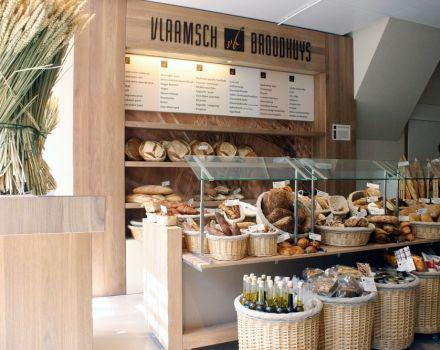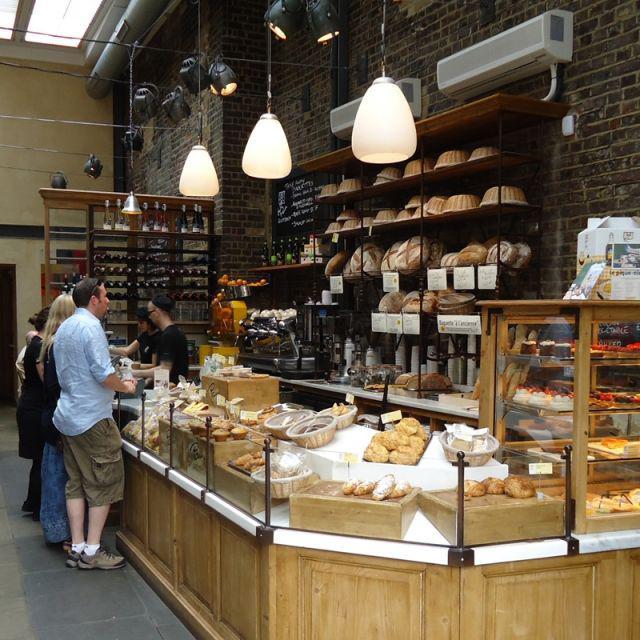The first image is the image on the left, the second image is the image on the right. Considering the images on both sides, is "Right image includes a row of at least 3 pendant lights." valid? Answer yes or no. Yes. 